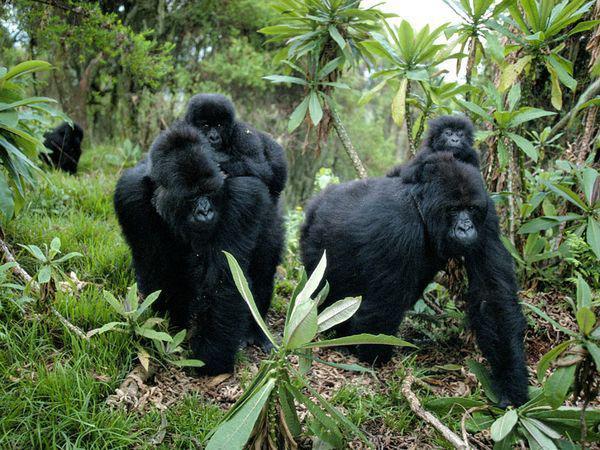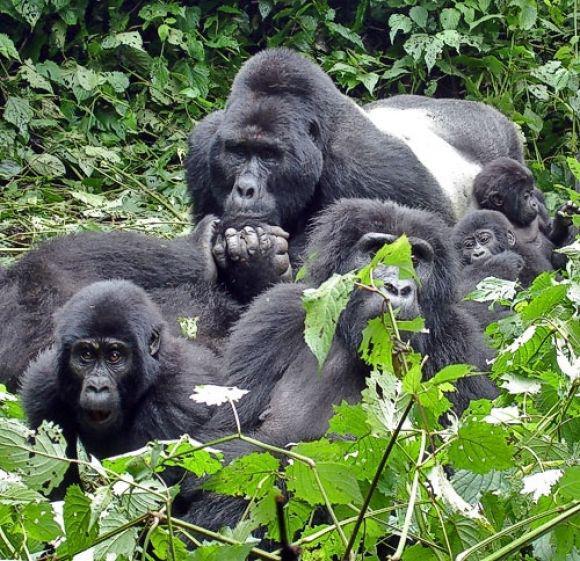The first image is the image on the left, the second image is the image on the right. Analyze the images presented: Is the assertion "One of the images shows at least one gorilla standing on its hands." valid? Answer yes or no. Yes. The first image is the image on the left, the second image is the image on the right. For the images displayed, is the sentence "Right image shows one foreground family-type gorilla group, which includes young gorillas." factually correct? Answer yes or no. Yes. 